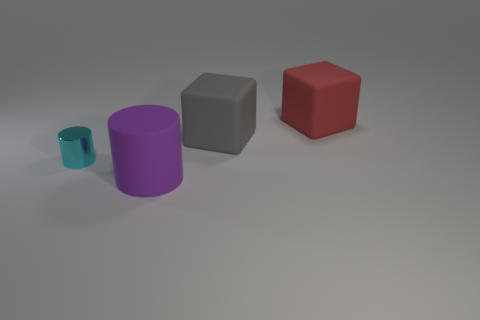What number of other things are the same material as the small cylinder?
Make the answer very short. 0. How many objects are small cyan objects or tiny blue metallic cubes?
Offer a terse response. 1. Are there more red matte blocks that are right of the tiny cyan shiny cylinder than cyan metallic objects that are behind the gray cube?
Keep it short and to the point. Yes. Do the thing that is behind the gray object and the large block left of the large red object have the same color?
Ensure brevity in your answer.  No. What is the size of the cyan thing that is to the left of the matte block that is to the left of the big thing that is behind the large gray rubber block?
Your response must be concise. Small. What color is the other object that is the same shape as the tiny thing?
Your answer should be compact. Purple. Are there more big red objects that are behind the big cylinder than cyan metallic spheres?
Your answer should be very brief. Yes. There is a big purple rubber thing; is its shape the same as the big gray thing that is behind the tiny shiny cylinder?
Your response must be concise. No. Are there any other things that are the same size as the cyan shiny cylinder?
Ensure brevity in your answer.  No. What size is the cyan metallic object that is the same shape as the purple matte object?
Offer a very short reply. Small. 